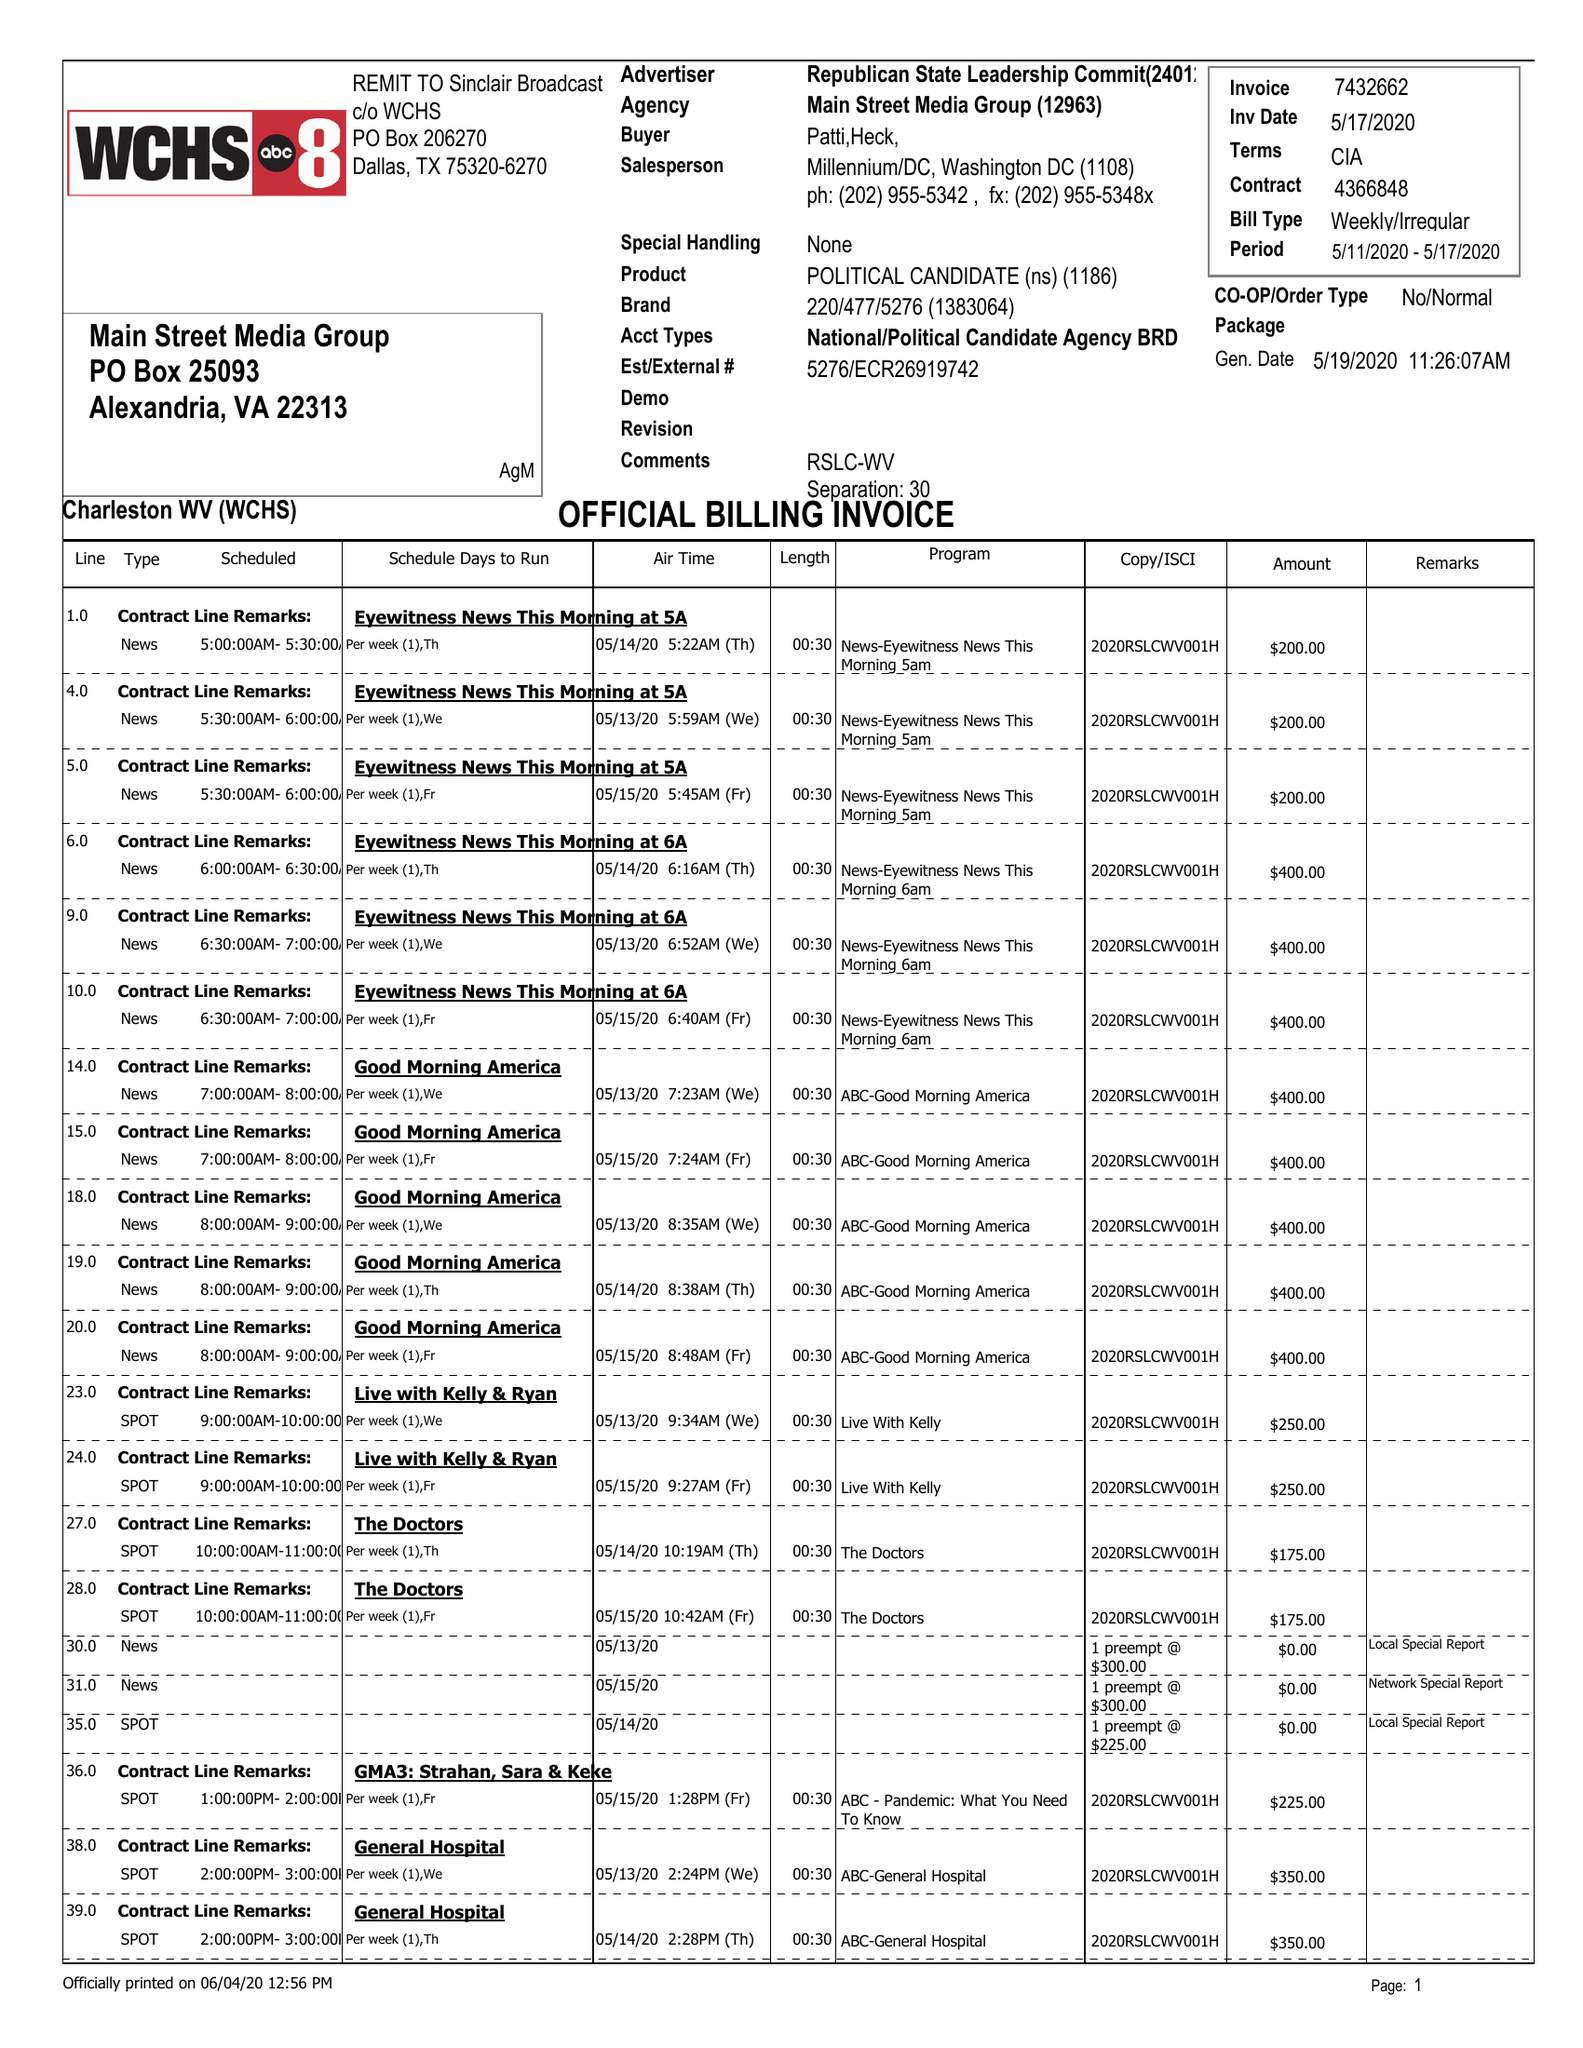What is the value for the advertiser?
Answer the question using a single word or phrase. NATIONAL/POLITICALCANDIDATEAGENCYBRD 